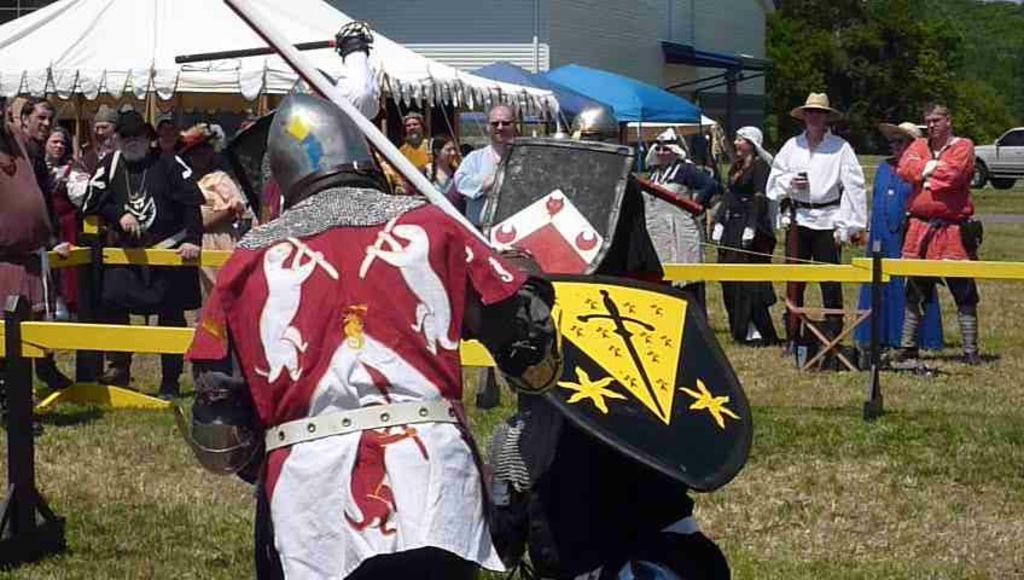What are the people in the image doing? The people in the image are in motion, holding shields and swords. What can be seen in the foreground of the image? There is grass visible in the foreground of the image. Can you describe the background of the image? In the background of the image, there are people, a fence, tents, a wall, a vehicle, grass, and trees. How many arms are visible in the image? There is no specific mention of arms in the image, but the people are holding shields and swords, which implies that their arms are in use. What type of flock can be seen in the image? There is no flock of animals present in the image; it features people holding shields and swords, as well as various background elements. 